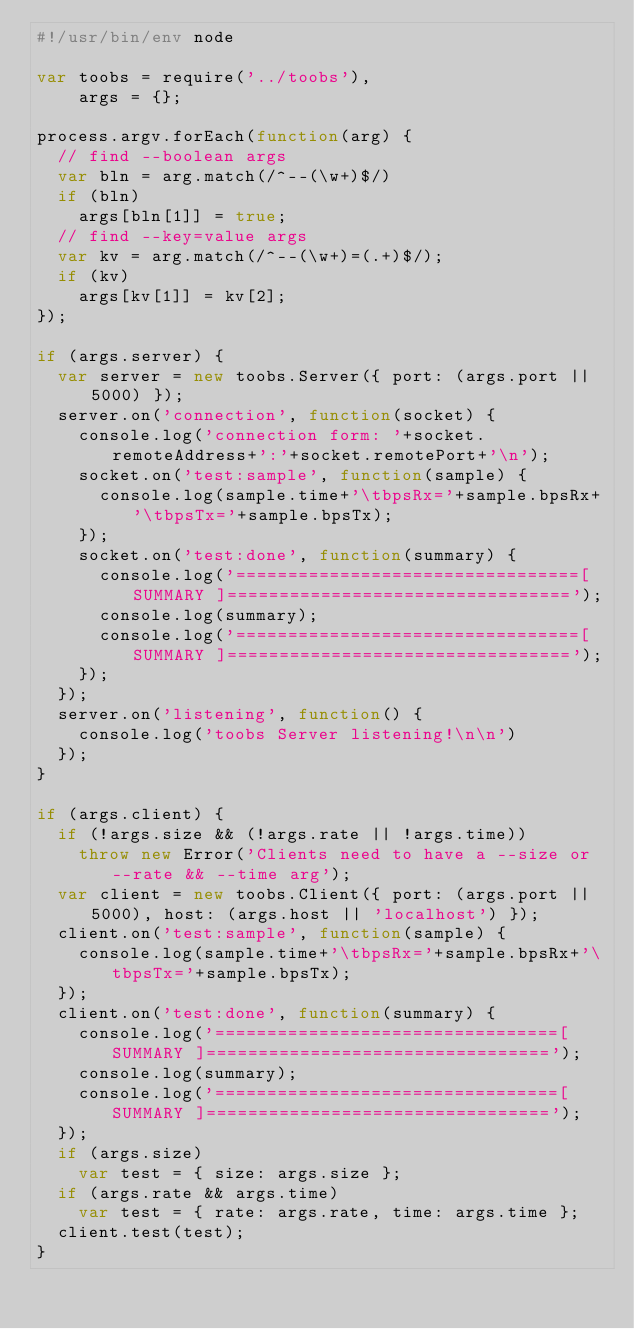Convert code to text. <code><loc_0><loc_0><loc_500><loc_500><_JavaScript_>#!/usr/bin/env node

var toobs = require('../toobs'),
    args = {};

process.argv.forEach(function(arg) {
  // find --boolean args
  var bln = arg.match(/^--(\w+)$/)
  if (bln)
    args[bln[1]] = true;
  // find --key=value args
  var kv = arg.match(/^--(\w+)=(.+)$/);
  if (kv)
    args[kv[1]] = kv[2];
});

if (args.server) {
  var server = new toobs.Server({ port: (args.port || 5000) });
  server.on('connection', function(socket) {
    console.log('connection form: '+socket.remoteAddress+':'+socket.remotePort+'\n');
    socket.on('test:sample', function(sample) {
      console.log(sample.time+'\tbpsRx='+sample.bpsRx+'\tbpsTx='+sample.bpsTx);
    });
    socket.on('test:done', function(summary) {
      console.log('=================================[ SUMMARY ]=================================');
      console.log(summary);
      console.log('=================================[ SUMMARY ]=================================');
    });
  });
  server.on('listening', function() {
    console.log('toobs Server listening!\n\n')
  });
}

if (args.client) {
  if (!args.size && (!args.rate || !args.time))
    throw new Error('Clients need to have a --size or --rate && --time arg');
  var client = new toobs.Client({ port: (args.port || 5000), host: (args.host || 'localhost') });
  client.on('test:sample', function(sample) {
    console.log(sample.time+'\tbpsRx='+sample.bpsRx+'\tbpsTx='+sample.bpsTx);
  });
  client.on('test:done', function(summary) {
    console.log('=================================[ SUMMARY ]=================================');
    console.log(summary);
    console.log('=================================[ SUMMARY ]=================================');
  });
  if (args.size)
    var test = { size: args.size };
  if (args.rate && args.time)
    var test = { rate: args.rate, time: args.time };
  client.test(test);
}
</code> 